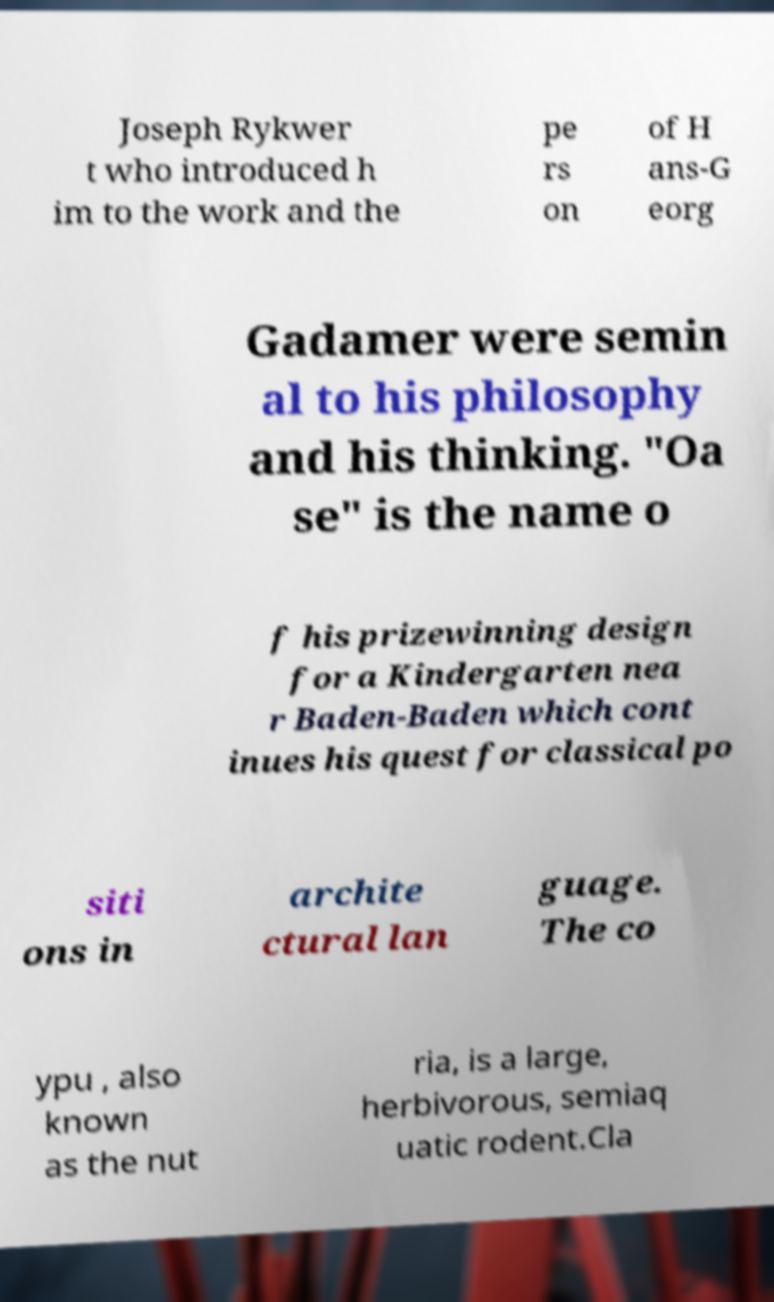Please read and relay the text visible in this image. What does it say? Joseph Rykwer t who introduced h im to the work and the pe rs on of H ans-G eorg Gadamer were semin al to his philosophy and his thinking. "Oa se" is the name o f his prizewinning design for a Kindergarten nea r Baden-Baden which cont inues his quest for classical po siti ons in archite ctural lan guage. The co ypu , also known as the nut ria, is a large, herbivorous, semiaq uatic rodent.Cla 